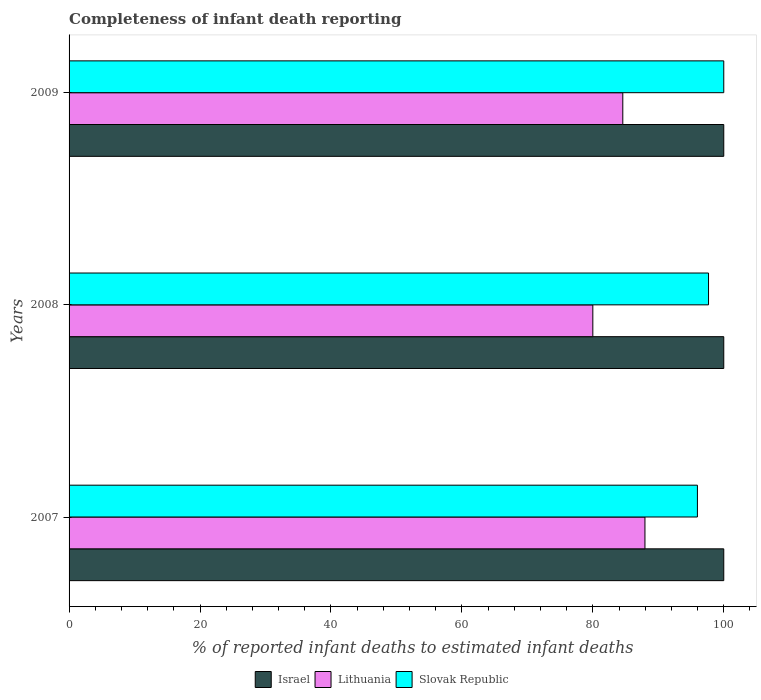How many different coloured bars are there?
Offer a very short reply. 3. How many groups of bars are there?
Offer a very short reply. 3. Are the number of bars per tick equal to the number of legend labels?
Your response must be concise. Yes. How many bars are there on the 3rd tick from the top?
Your response must be concise. 3. How many bars are there on the 2nd tick from the bottom?
Offer a terse response. 3. What is the label of the 3rd group of bars from the top?
Make the answer very short. 2007. In how many cases, is the number of bars for a given year not equal to the number of legend labels?
Your response must be concise. 0. In which year was the percentage of infant deaths reported in Slovak Republic maximum?
Your answer should be compact. 2009. In which year was the percentage of infant deaths reported in Israel minimum?
Make the answer very short. 2007. What is the total percentage of infant deaths reported in Israel in the graph?
Your answer should be compact. 300. What is the difference between the percentage of infant deaths reported in Slovak Republic in 2008 and that in 2009?
Give a very brief answer. -2.33. What is the difference between the percentage of infant deaths reported in Lithuania in 2009 and the percentage of infant deaths reported in Israel in 2008?
Provide a short and direct response. -15.42. What is the average percentage of infant deaths reported in Slovak Republic per year?
Your answer should be very brief. 97.88. What is the ratio of the percentage of infant deaths reported in Slovak Republic in 2008 to that in 2009?
Ensure brevity in your answer.  0.98. Is the difference between the percentage of infant deaths reported in Lithuania in 2007 and 2008 greater than the difference between the percentage of infant deaths reported in Israel in 2007 and 2008?
Your answer should be compact. Yes. What is the difference between the highest and the second highest percentage of infant deaths reported in Slovak Republic?
Provide a succinct answer. 2.33. What is the difference between the highest and the lowest percentage of infant deaths reported in Lithuania?
Offer a terse response. 7.96. Is the sum of the percentage of infant deaths reported in Slovak Republic in 2007 and 2009 greater than the maximum percentage of infant deaths reported in Lithuania across all years?
Your response must be concise. Yes. What does the 2nd bar from the top in 2007 represents?
Provide a succinct answer. Lithuania. What does the 1st bar from the bottom in 2009 represents?
Offer a very short reply. Israel. Is it the case that in every year, the sum of the percentage of infant deaths reported in Slovak Republic and percentage of infant deaths reported in Israel is greater than the percentage of infant deaths reported in Lithuania?
Make the answer very short. Yes. Are all the bars in the graph horizontal?
Your answer should be compact. Yes. How many years are there in the graph?
Provide a succinct answer. 3. What is the difference between two consecutive major ticks on the X-axis?
Your answer should be very brief. 20. Are the values on the major ticks of X-axis written in scientific E-notation?
Your answer should be very brief. No. What is the title of the graph?
Offer a terse response. Completeness of infant death reporting. What is the label or title of the X-axis?
Offer a very short reply. % of reported infant deaths to estimated infant deaths. What is the % of reported infant deaths to estimated infant deaths of Lithuania in 2007?
Provide a succinct answer. 87.96. What is the % of reported infant deaths to estimated infant deaths of Slovak Republic in 2007?
Offer a terse response. 95.98. What is the % of reported infant deaths to estimated infant deaths in Israel in 2008?
Your answer should be very brief. 100. What is the % of reported infant deaths to estimated infant deaths in Slovak Republic in 2008?
Ensure brevity in your answer.  97.67. What is the % of reported infant deaths to estimated infant deaths in Lithuania in 2009?
Give a very brief answer. 84.58. What is the % of reported infant deaths to estimated infant deaths in Slovak Republic in 2009?
Offer a very short reply. 100. Across all years, what is the maximum % of reported infant deaths to estimated infant deaths in Lithuania?
Offer a terse response. 87.96. Across all years, what is the minimum % of reported infant deaths to estimated infant deaths of Israel?
Offer a very short reply. 100. Across all years, what is the minimum % of reported infant deaths to estimated infant deaths in Lithuania?
Offer a terse response. 80. Across all years, what is the minimum % of reported infant deaths to estimated infant deaths of Slovak Republic?
Give a very brief answer. 95.98. What is the total % of reported infant deaths to estimated infant deaths of Israel in the graph?
Provide a short and direct response. 300. What is the total % of reported infant deaths to estimated infant deaths of Lithuania in the graph?
Make the answer very short. 252.54. What is the total % of reported infant deaths to estimated infant deaths in Slovak Republic in the graph?
Your response must be concise. 293.65. What is the difference between the % of reported infant deaths to estimated infant deaths of Israel in 2007 and that in 2008?
Provide a succinct answer. 0. What is the difference between the % of reported infant deaths to estimated infant deaths in Lithuania in 2007 and that in 2008?
Provide a short and direct response. 7.96. What is the difference between the % of reported infant deaths to estimated infant deaths in Slovak Republic in 2007 and that in 2008?
Offer a terse response. -1.7. What is the difference between the % of reported infant deaths to estimated infant deaths of Israel in 2007 and that in 2009?
Provide a short and direct response. 0. What is the difference between the % of reported infant deaths to estimated infant deaths of Lithuania in 2007 and that in 2009?
Your answer should be very brief. 3.38. What is the difference between the % of reported infant deaths to estimated infant deaths of Slovak Republic in 2007 and that in 2009?
Ensure brevity in your answer.  -4.02. What is the difference between the % of reported infant deaths to estimated infant deaths of Lithuania in 2008 and that in 2009?
Provide a succinct answer. -4.58. What is the difference between the % of reported infant deaths to estimated infant deaths of Slovak Republic in 2008 and that in 2009?
Your answer should be compact. -2.33. What is the difference between the % of reported infant deaths to estimated infant deaths of Israel in 2007 and the % of reported infant deaths to estimated infant deaths of Lithuania in 2008?
Ensure brevity in your answer.  20. What is the difference between the % of reported infant deaths to estimated infant deaths in Israel in 2007 and the % of reported infant deaths to estimated infant deaths in Slovak Republic in 2008?
Make the answer very short. 2.33. What is the difference between the % of reported infant deaths to estimated infant deaths of Lithuania in 2007 and the % of reported infant deaths to estimated infant deaths of Slovak Republic in 2008?
Provide a short and direct response. -9.71. What is the difference between the % of reported infant deaths to estimated infant deaths in Israel in 2007 and the % of reported infant deaths to estimated infant deaths in Lithuania in 2009?
Your response must be concise. 15.42. What is the difference between the % of reported infant deaths to estimated infant deaths in Lithuania in 2007 and the % of reported infant deaths to estimated infant deaths in Slovak Republic in 2009?
Keep it short and to the point. -12.04. What is the difference between the % of reported infant deaths to estimated infant deaths of Israel in 2008 and the % of reported infant deaths to estimated infant deaths of Lithuania in 2009?
Your answer should be very brief. 15.42. What is the difference between the % of reported infant deaths to estimated infant deaths in Israel in 2008 and the % of reported infant deaths to estimated infant deaths in Slovak Republic in 2009?
Your answer should be very brief. 0. What is the average % of reported infant deaths to estimated infant deaths in Israel per year?
Offer a terse response. 100. What is the average % of reported infant deaths to estimated infant deaths of Lithuania per year?
Provide a short and direct response. 84.18. What is the average % of reported infant deaths to estimated infant deaths of Slovak Republic per year?
Provide a short and direct response. 97.88. In the year 2007, what is the difference between the % of reported infant deaths to estimated infant deaths in Israel and % of reported infant deaths to estimated infant deaths in Lithuania?
Provide a succinct answer. 12.04. In the year 2007, what is the difference between the % of reported infant deaths to estimated infant deaths in Israel and % of reported infant deaths to estimated infant deaths in Slovak Republic?
Offer a very short reply. 4.02. In the year 2007, what is the difference between the % of reported infant deaths to estimated infant deaths in Lithuania and % of reported infant deaths to estimated infant deaths in Slovak Republic?
Make the answer very short. -8.01. In the year 2008, what is the difference between the % of reported infant deaths to estimated infant deaths of Israel and % of reported infant deaths to estimated infant deaths of Slovak Republic?
Make the answer very short. 2.33. In the year 2008, what is the difference between the % of reported infant deaths to estimated infant deaths in Lithuania and % of reported infant deaths to estimated infant deaths in Slovak Republic?
Offer a terse response. -17.67. In the year 2009, what is the difference between the % of reported infant deaths to estimated infant deaths in Israel and % of reported infant deaths to estimated infant deaths in Lithuania?
Your answer should be very brief. 15.42. In the year 2009, what is the difference between the % of reported infant deaths to estimated infant deaths in Lithuania and % of reported infant deaths to estimated infant deaths in Slovak Republic?
Your answer should be compact. -15.42. What is the ratio of the % of reported infant deaths to estimated infant deaths in Israel in 2007 to that in 2008?
Your response must be concise. 1. What is the ratio of the % of reported infant deaths to estimated infant deaths of Lithuania in 2007 to that in 2008?
Make the answer very short. 1.1. What is the ratio of the % of reported infant deaths to estimated infant deaths of Slovak Republic in 2007 to that in 2008?
Offer a very short reply. 0.98. What is the ratio of the % of reported infant deaths to estimated infant deaths of Slovak Republic in 2007 to that in 2009?
Keep it short and to the point. 0.96. What is the ratio of the % of reported infant deaths to estimated infant deaths in Lithuania in 2008 to that in 2009?
Your answer should be very brief. 0.95. What is the ratio of the % of reported infant deaths to estimated infant deaths of Slovak Republic in 2008 to that in 2009?
Your answer should be compact. 0.98. What is the difference between the highest and the second highest % of reported infant deaths to estimated infant deaths in Israel?
Your response must be concise. 0. What is the difference between the highest and the second highest % of reported infant deaths to estimated infant deaths of Lithuania?
Provide a short and direct response. 3.38. What is the difference between the highest and the second highest % of reported infant deaths to estimated infant deaths in Slovak Republic?
Keep it short and to the point. 2.33. What is the difference between the highest and the lowest % of reported infant deaths to estimated infant deaths of Lithuania?
Provide a short and direct response. 7.96. What is the difference between the highest and the lowest % of reported infant deaths to estimated infant deaths of Slovak Republic?
Give a very brief answer. 4.02. 